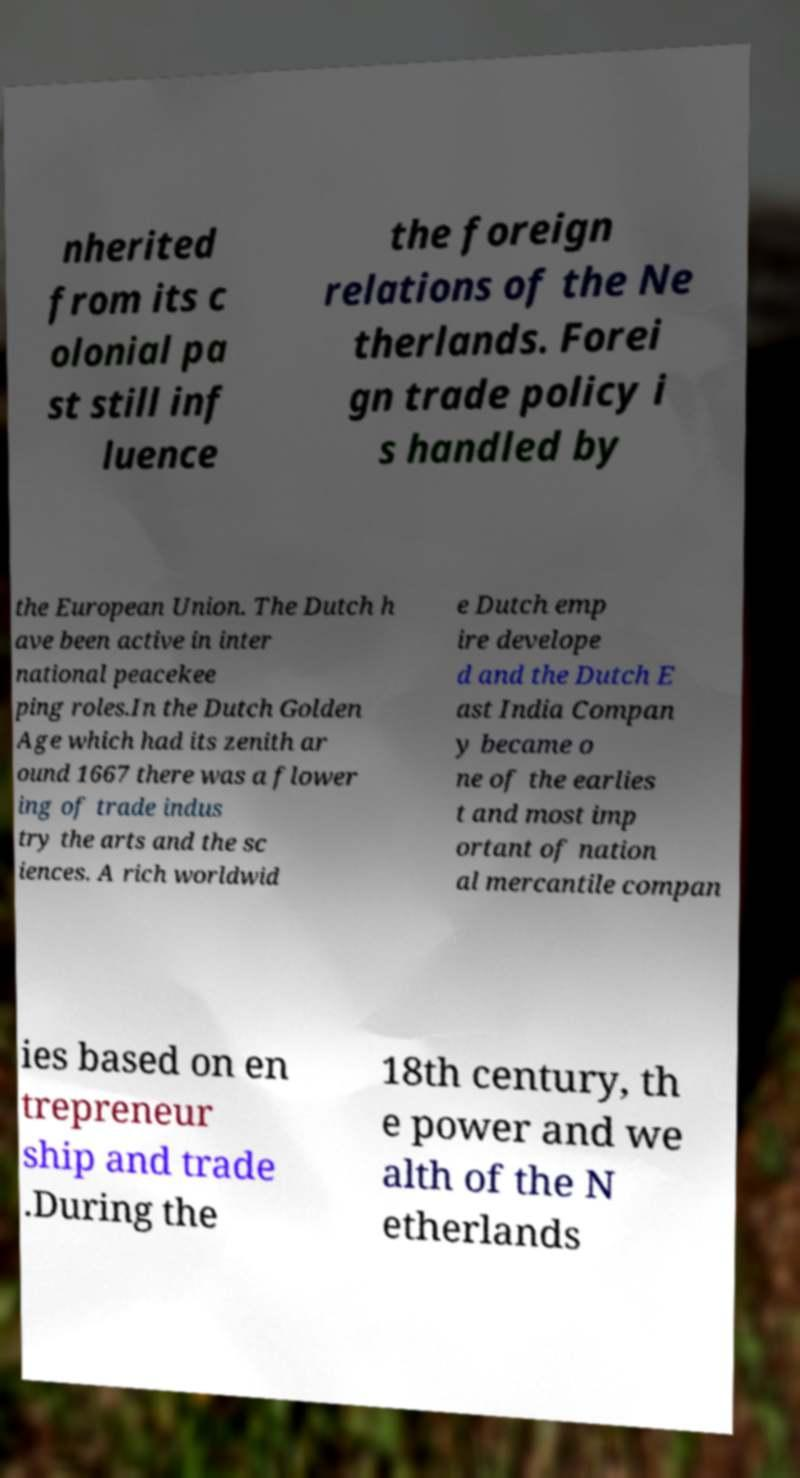For documentation purposes, I need the text within this image transcribed. Could you provide that? nherited from its c olonial pa st still inf luence the foreign relations of the Ne therlands. Forei gn trade policy i s handled by the European Union. The Dutch h ave been active in inter national peacekee ping roles.In the Dutch Golden Age which had its zenith ar ound 1667 there was a flower ing of trade indus try the arts and the sc iences. A rich worldwid e Dutch emp ire develope d and the Dutch E ast India Compan y became o ne of the earlies t and most imp ortant of nation al mercantile compan ies based on en trepreneur ship and trade .During the 18th century, th e power and we alth of the N etherlands 